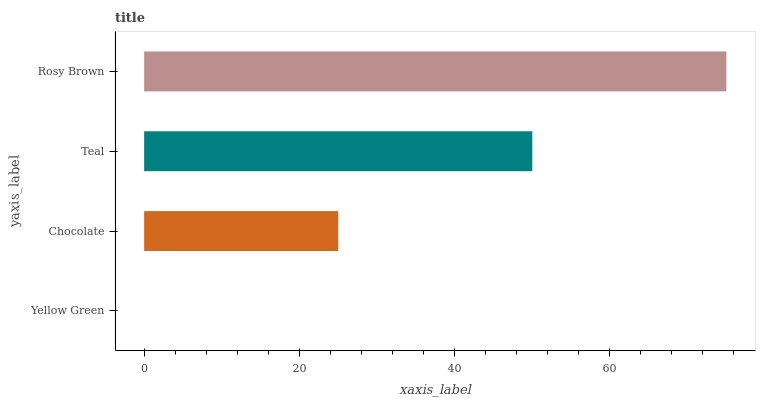Is Yellow Green the minimum?
Answer yes or no. Yes. Is Rosy Brown the maximum?
Answer yes or no. Yes. Is Chocolate the minimum?
Answer yes or no. No. Is Chocolate the maximum?
Answer yes or no. No. Is Chocolate greater than Yellow Green?
Answer yes or no. Yes. Is Yellow Green less than Chocolate?
Answer yes or no. Yes. Is Yellow Green greater than Chocolate?
Answer yes or no. No. Is Chocolate less than Yellow Green?
Answer yes or no. No. Is Teal the high median?
Answer yes or no. Yes. Is Chocolate the low median?
Answer yes or no. Yes. Is Chocolate the high median?
Answer yes or no. No. Is Teal the low median?
Answer yes or no. No. 